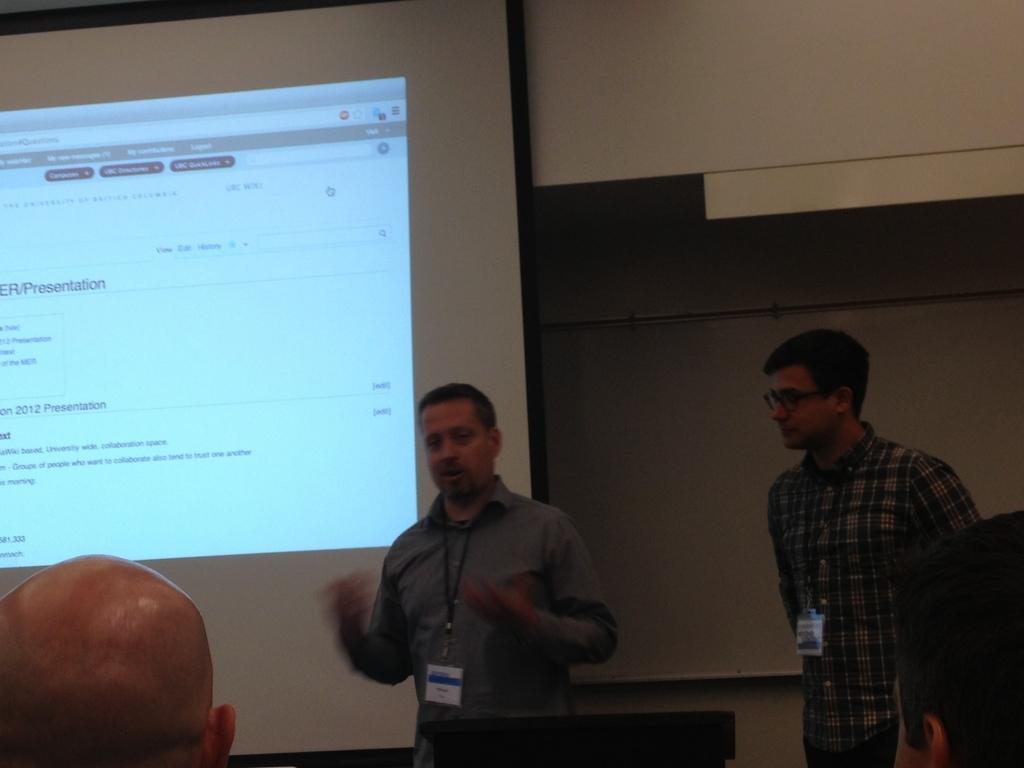In one or two sentences, can you explain what this image depicts? Here in this picture we can see two men standing over a place and both of them are having ID cards on them and the person on left side is speaking something and behind them we can see a projector screen with something projected on it over there and in front of them we can see people sitting over there. 